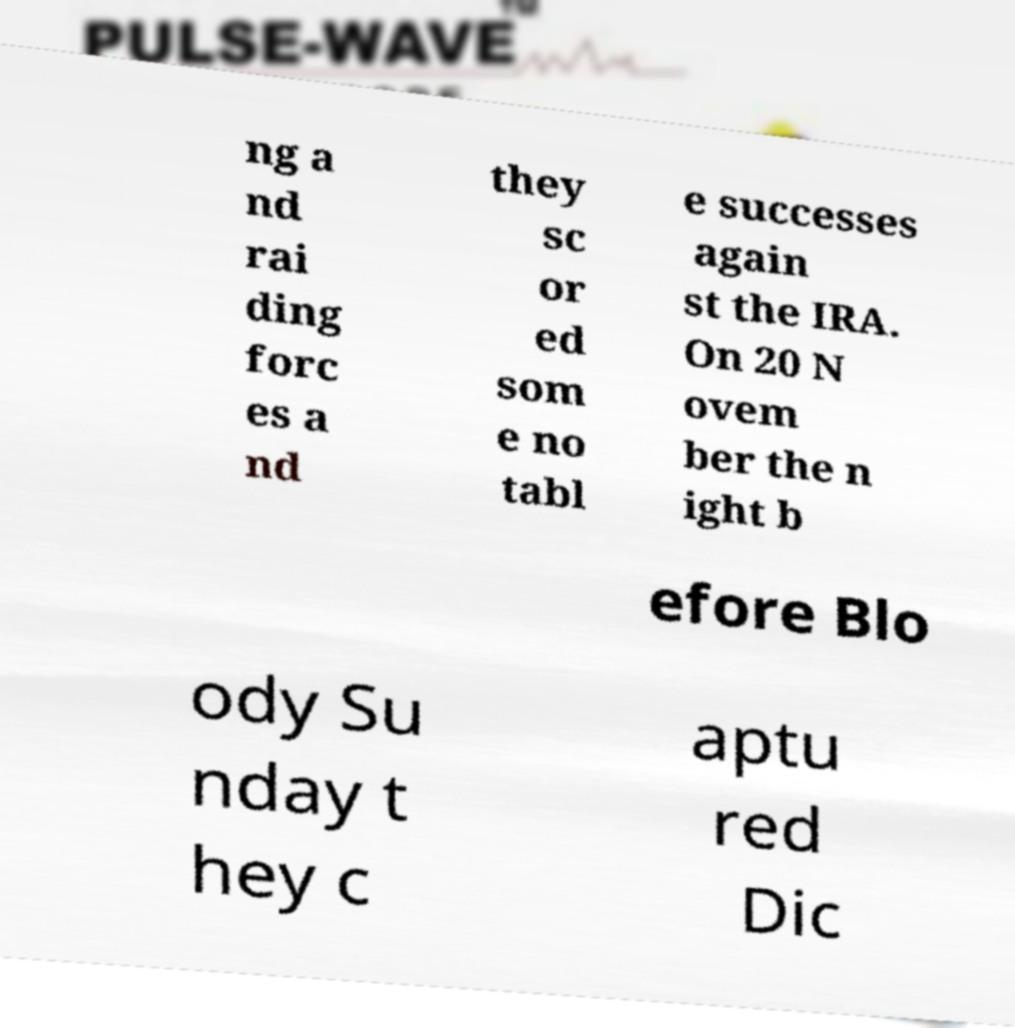What messages or text are displayed in this image? I need them in a readable, typed format. ng a nd rai ding forc es a nd they sc or ed som e no tabl e successes again st the IRA. On 20 N ovem ber the n ight b efore Blo ody Su nday t hey c aptu red Dic 